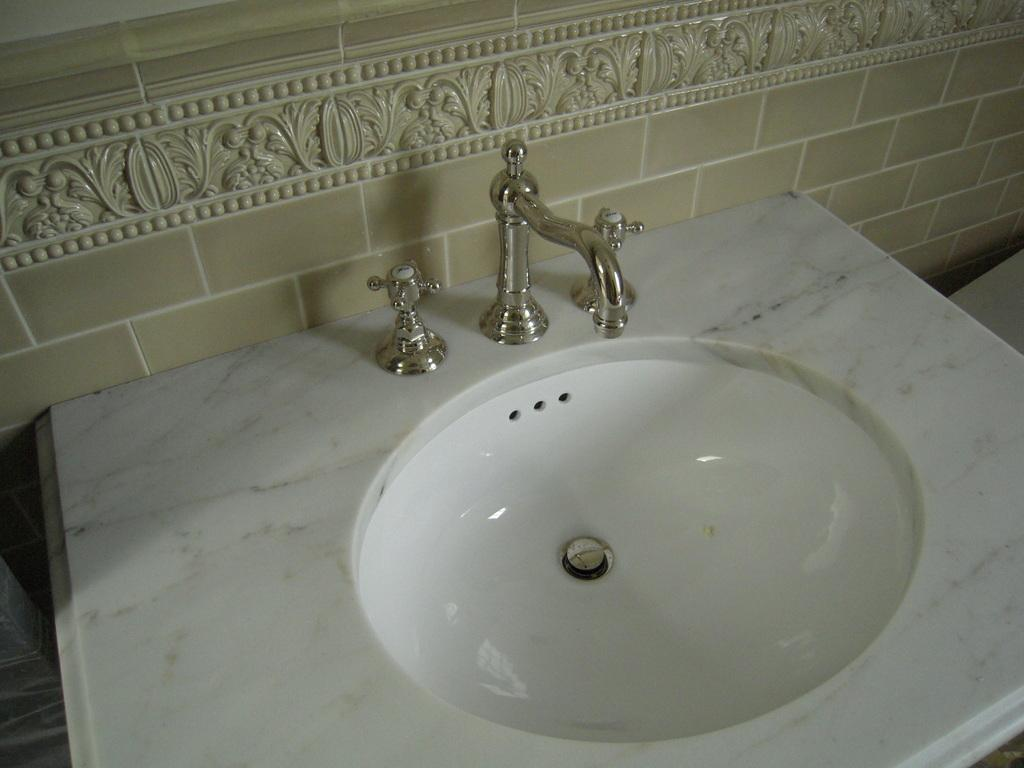What is the main object in the foreground of the image? There is a marble sink in the foreground of the image. What feature is present on the sink? There are taps on the sink. What type of wall can be seen in the background of the image? There is a tile wall in the background of the image. How many mice are sitting on the books in the image? There are no mice or books present in the image. 